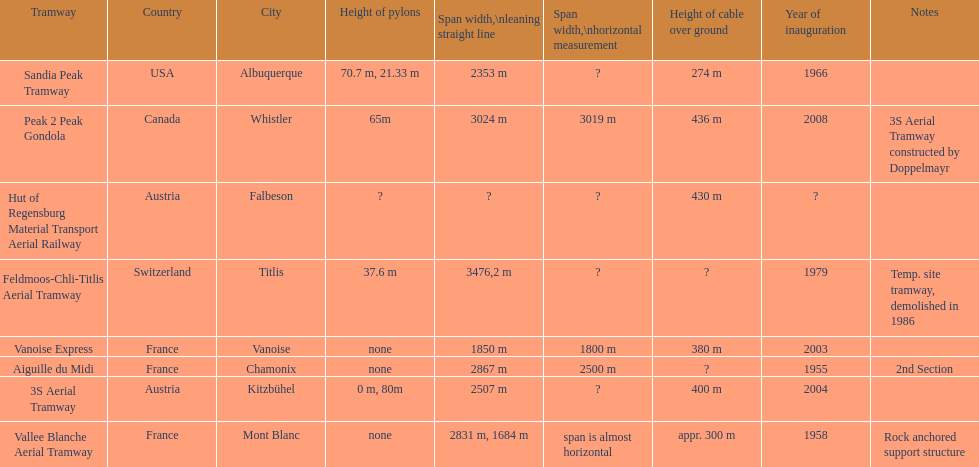Could you parse the entire table as a dict? {'header': ['Tramway', 'Country', 'City', 'Height of pylons', 'Span\xa0width,\\nleaning straight line', 'Span width,\\nhorizontal measurement', 'Height of cable over ground', 'Year of inauguration', 'Notes'], 'rows': [['Sandia Peak Tramway', 'USA', 'Albuquerque', '70.7 m, 21.33 m', '2353 m', '?', '274 m', '1966', ''], ['Peak 2 Peak Gondola', 'Canada', 'Whistler', '65m', '3024 m', '3019 m', '436 m', '2008', '3S Aerial Tramway constructed by Doppelmayr'], ['Hut of Regensburg Material Transport Aerial Railway', 'Austria', 'Falbeson', '?', '?', '?', '430 m', '?', ''], ['Feldmoos-Chli-Titlis Aerial Tramway', 'Switzerland', 'Titlis', '37.6 m', '3476,2 m', '?', '?', '1979', 'Temp. site tramway, demolished in 1986'], ['Vanoise Express', 'France', 'Vanoise', 'none', '1850 m', '1800 m', '380 m', '2003', ''], ['Aiguille du Midi', 'France', 'Chamonix', 'none', '2867 m', '2500 m', '?', '1955', '2nd Section'], ['3S Aerial Tramway', 'Austria', 'Kitzbühel', '0 m, 80m', '2507 m', '?', '400 m', '2004', ''], ['Vallee Blanche Aerial Tramway', 'France', 'Mont Blanc', 'none', '2831 m, 1684 m', 'span is almost horizontal', 'appr. 300 m', '1958', 'Rock anchored support structure']]} Which tramway was built directly before the 3s aeriral tramway? Vanoise Express. 